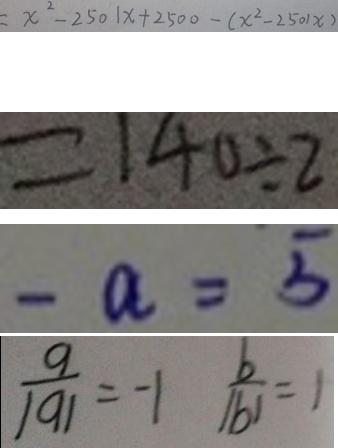Convert formula to latex. <formula><loc_0><loc_0><loc_500><loc_500>= x ^ { 2 } - 2 5 0 1 x + 2 5 0 0 - ( x ^ { 2 } - 2 5 0 1 x ) 
 = 1 4 0 \div 2 
 - a = 5 
 \frac { a } { \vert a \vert } = - 1 \frac { b } { \vert b \vert } = 1</formula> 